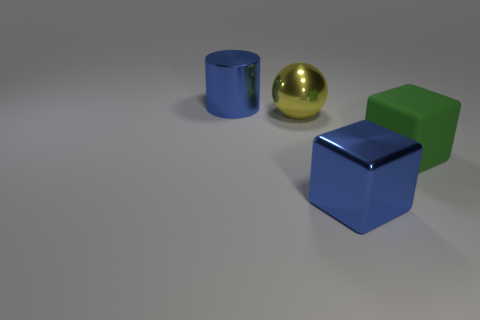Subtract all cyan cylinders. Subtract all brown blocks. How many cylinders are left? 1 Add 3 blue matte blocks. How many objects exist? 7 Subtract all cylinders. How many objects are left? 3 Subtract all cyan rubber things. Subtract all large yellow balls. How many objects are left? 3 Add 2 big cubes. How many big cubes are left? 4 Add 4 large blue shiny blocks. How many large blue shiny blocks exist? 5 Subtract 0 brown blocks. How many objects are left? 4 